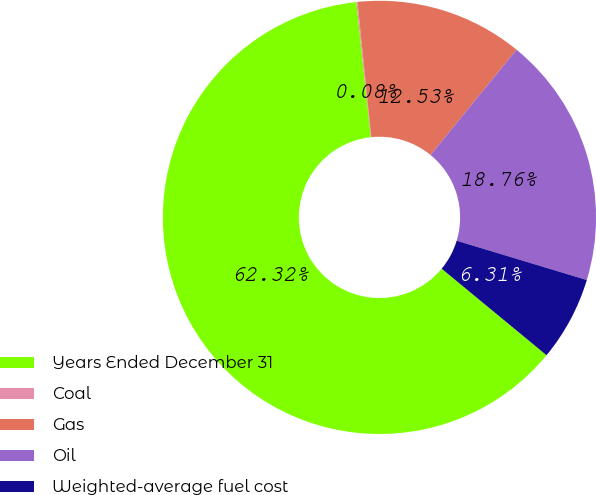Convert chart to OTSL. <chart><loc_0><loc_0><loc_500><loc_500><pie_chart><fcel>Years Ended December 31<fcel>Coal<fcel>Gas<fcel>Oil<fcel>Weighted-average fuel cost<nl><fcel>62.32%<fcel>0.08%<fcel>12.53%<fcel>18.76%<fcel>6.31%<nl></chart> 